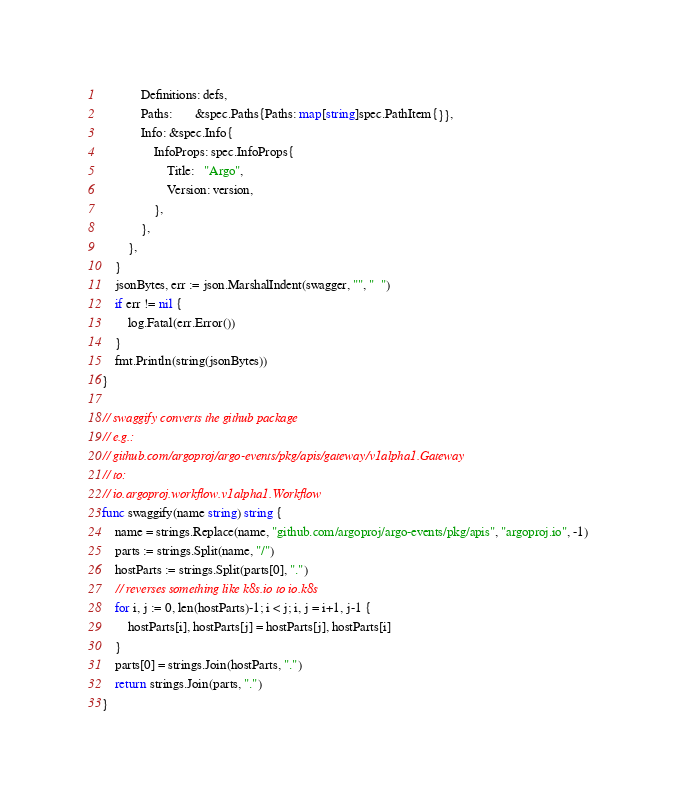<code> <loc_0><loc_0><loc_500><loc_500><_Go_>			Definitions: defs,
			Paths:       &spec.Paths{Paths: map[string]spec.PathItem{}},
			Info: &spec.Info{
				InfoProps: spec.InfoProps{
					Title:   "Argo",
					Version: version,
				},
			},
		},
	}
	jsonBytes, err := json.MarshalIndent(swagger, "", "  ")
	if err != nil {
		log.Fatal(err.Error())
	}
	fmt.Println(string(jsonBytes))
}

// swaggify converts the github package
// e.g.:
// github.com/argoproj/argo-events/pkg/apis/gateway/v1alpha1.Gateway
// to:
// io.argoproj.workflow.v1alpha1.Workflow
func swaggify(name string) string {
	name = strings.Replace(name, "github.com/argoproj/argo-events/pkg/apis", "argoproj.io", -1)
	parts := strings.Split(name, "/")
	hostParts := strings.Split(parts[0], ".")
	// reverses something like k8s.io to io.k8s
	for i, j := 0, len(hostParts)-1; i < j; i, j = i+1, j-1 {
		hostParts[i], hostParts[j] = hostParts[j], hostParts[i]
	}
	parts[0] = strings.Join(hostParts, ".")
	return strings.Join(parts, ".")
}
</code> 